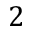Convert formula to latex. <formula><loc_0><loc_0><loc_500><loc_500>2</formula> 